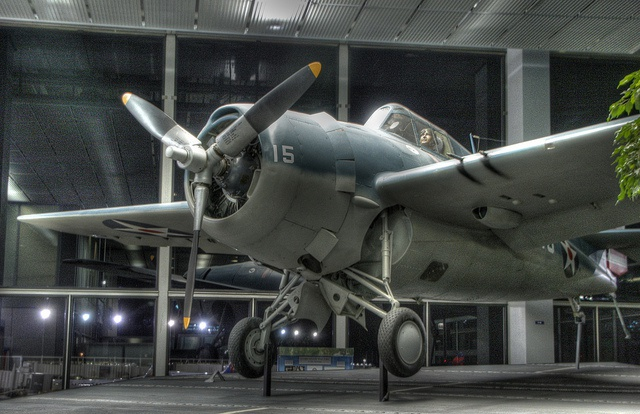Describe the objects in this image and their specific colors. I can see airplane in gray, black, darkgreen, and darkgray tones and people in gray, darkgray, and beige tones in this image. 